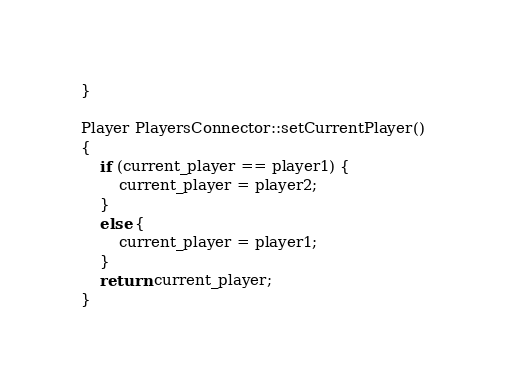Convert code to text. <code><loc_0><loc_0><loc_500><loc_500><_C++_>}

Player PlayersConnector::setCurrentPlayer()
{
    if (current_player == player1) {
        current_player = player2;
    }
    else {
        current_player = player1;
    }
    return current_player;
}
</code> 